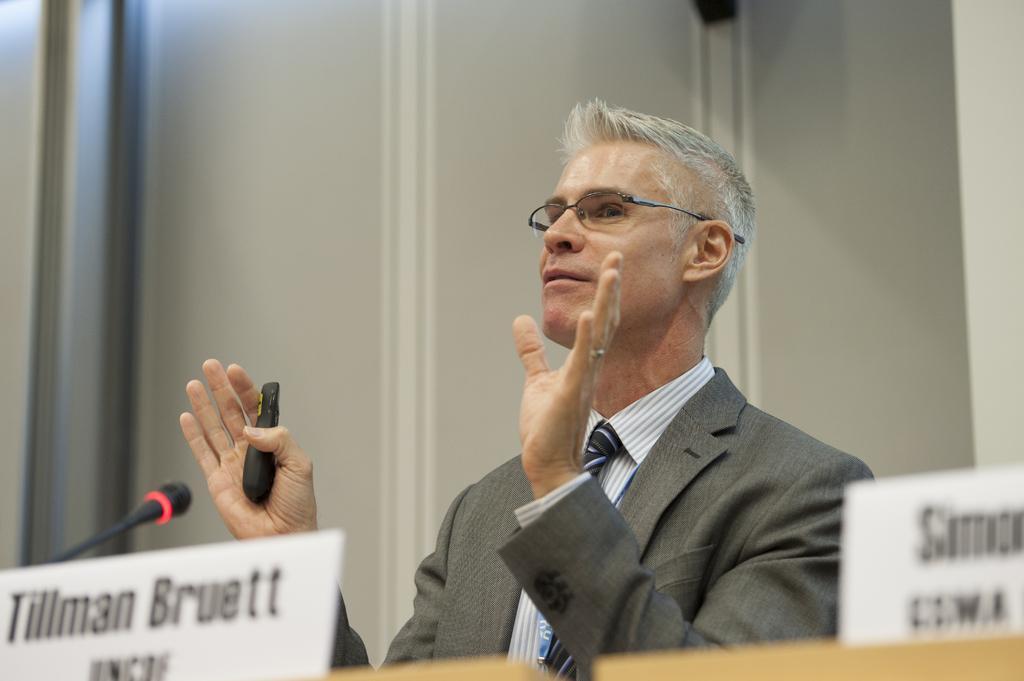Could you give a brief overview of what you see in this image? A person is standing wearing a suit and holding an object in his hand. There are name stands and a microphone. 